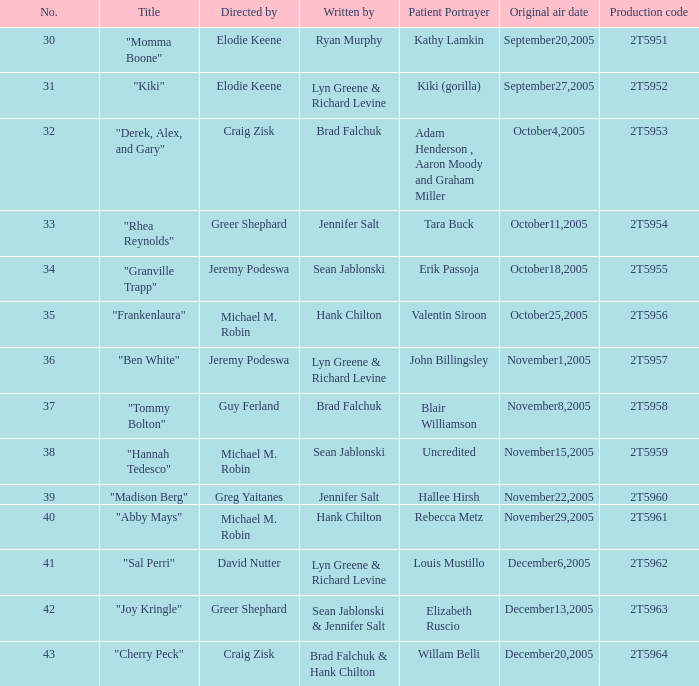In the episode directed by craig zisk and written by brad falchuk, what is the count of patient portrayers? 1.0. 